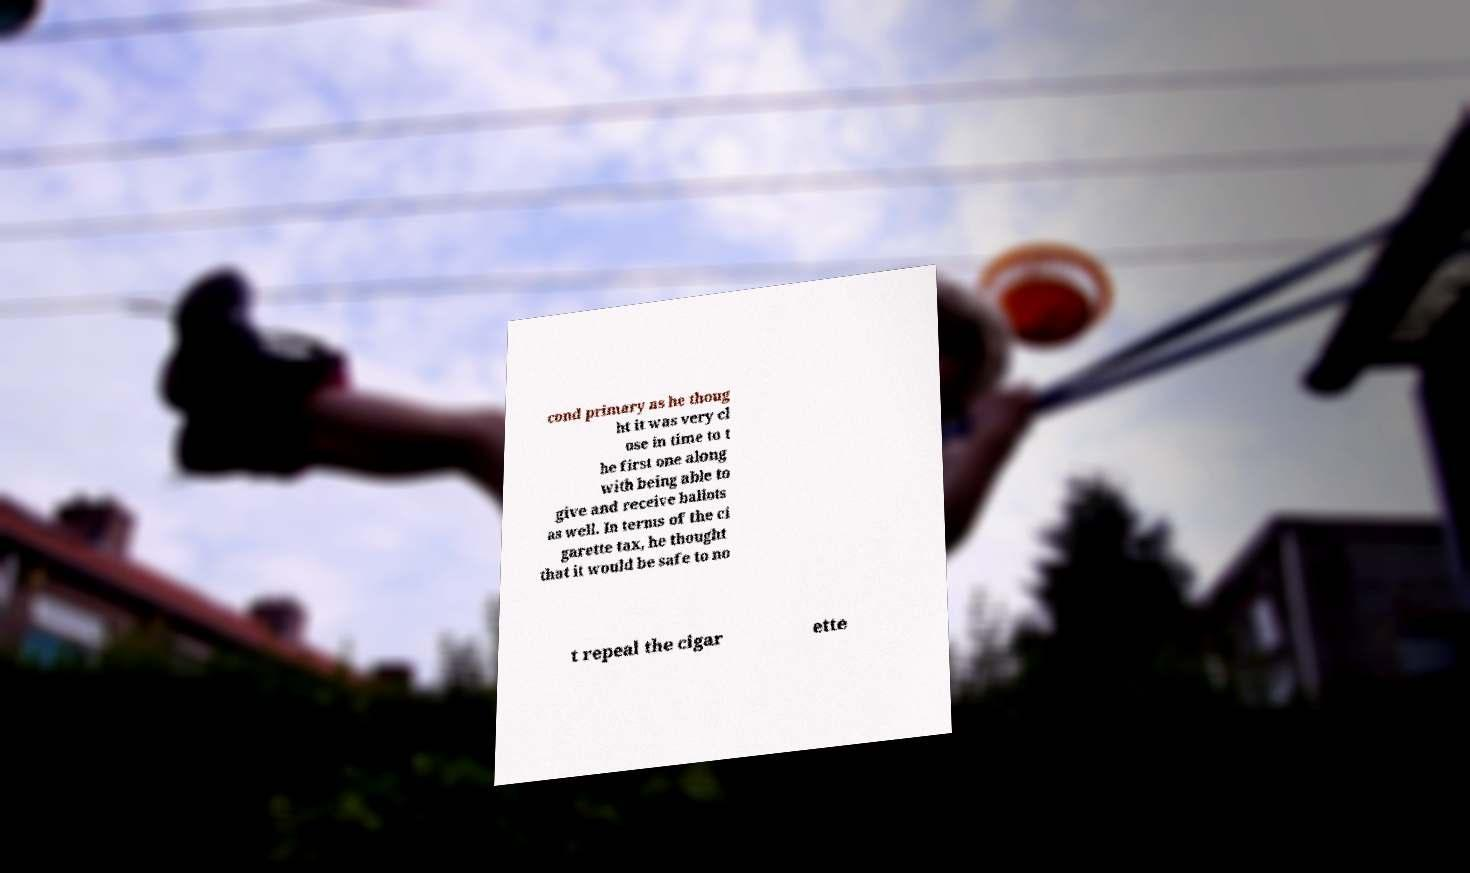Can you read and provide the text displayed in the image?This photo seems to have some interesting text. Can you extract and type it out for me? cond primary as he thoug ht it was very cl ose in time to t he first one along with being able to give and receive ballots as well. In terms of the ci garette tax, he thought that it would be safe to no t repeal the cigar ette 